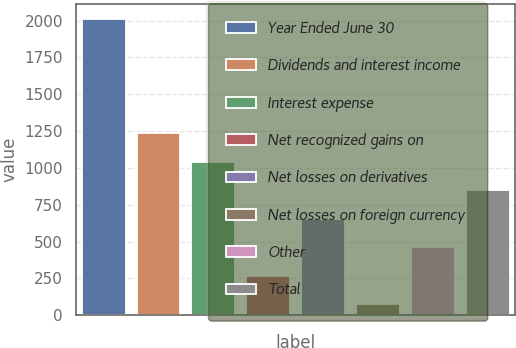<chart> <loc_0><loc_0><loc_500><loc_500><bar_chart><fcel>Year Ended June 30<fcel>Dividends and interest income<fcel>Interest expense<fcel>Net recognized gains on<fcel>Net losses on derivatives<fcel>Net losses on foreign currency<fcel>Other<fcel>Total<nl><fcel>2013<fcel>1237.4<fcel>1043.5<fcel>267.9<fcel>655.7<fcel>74<fcel>461.8<fcel>849.6<nl></chart> 